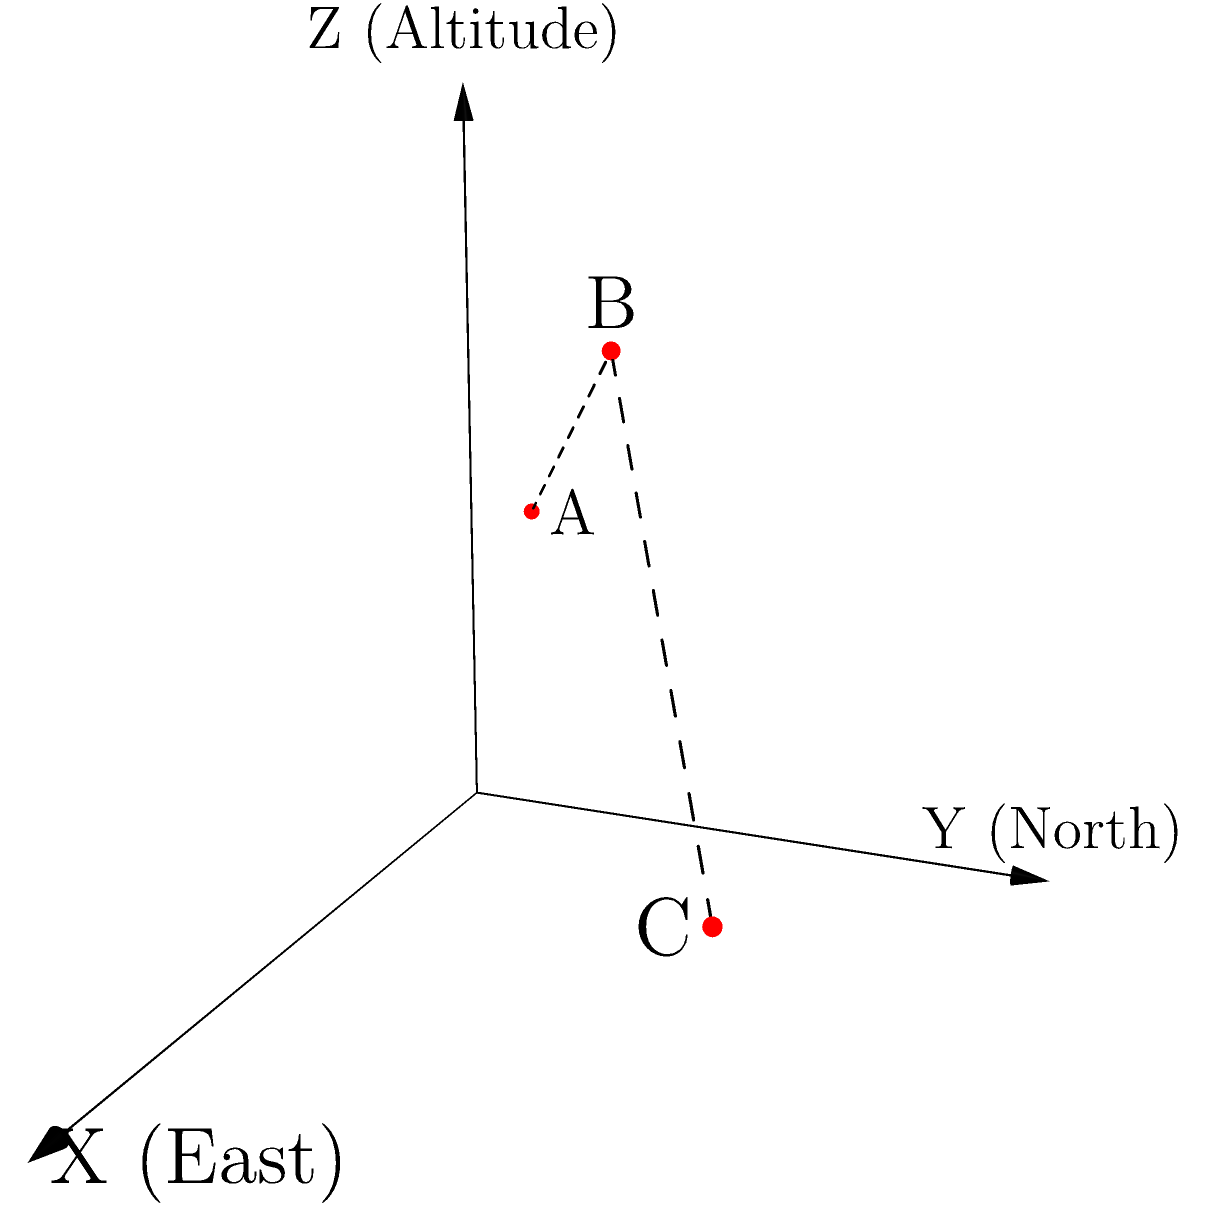In a study of indigenous population density across a mountainous region, three sample points (A, B, and C) were recorded using a 3D coordinate system. The X-axis represents distance eastward, the Y-axis represents distance northward, and the Z-axis represents altitude, all measured in kilometers. Given the coordinates A(1,1,2), B(2,2,3), and C(3,3,1), calculate the population density gradient (change in density per unit distance) between points A and C along their direct path. To solve this problem, we'll follow these steps:

1) First, we need to calculate the distance between points A and C:
   $$ d = \sqrt{(x_C - x_A)^2 + (y_C - y_A)^2 + (z_C - z_A)^2} $$
   $$ d = \sqrt{(3-1)^2 + (3-1)^2 + (1-2)^2} = \sqrt{4 + 4 + 1} = \sqrt{9} = 3 \text{ km} $$

2) Now, let's assume the population density at point A is $D_A$ and at point C is $D_C$.

3) The population density gradient is the change in density per unit distance:
   $$ \text{Gradient} = \frac{D_C - D_A}{d} = \frac{\Delta D}{3} \text{ people/km}^3\text{/km} $$

4) This can be simplified to:
   $$ \text{Gradient} = \frac{\Delta D}{3} \text{ people/km}^4 $$

Where $\Delta D$ represents the difference in population density between points C and A.

This gradient represents how the population density changes along the direct path from A to C, taking into account both horizontal distance and altitude change.
Answer: $\frac{\Delta D}{3} \text{ people/km}^4$ 